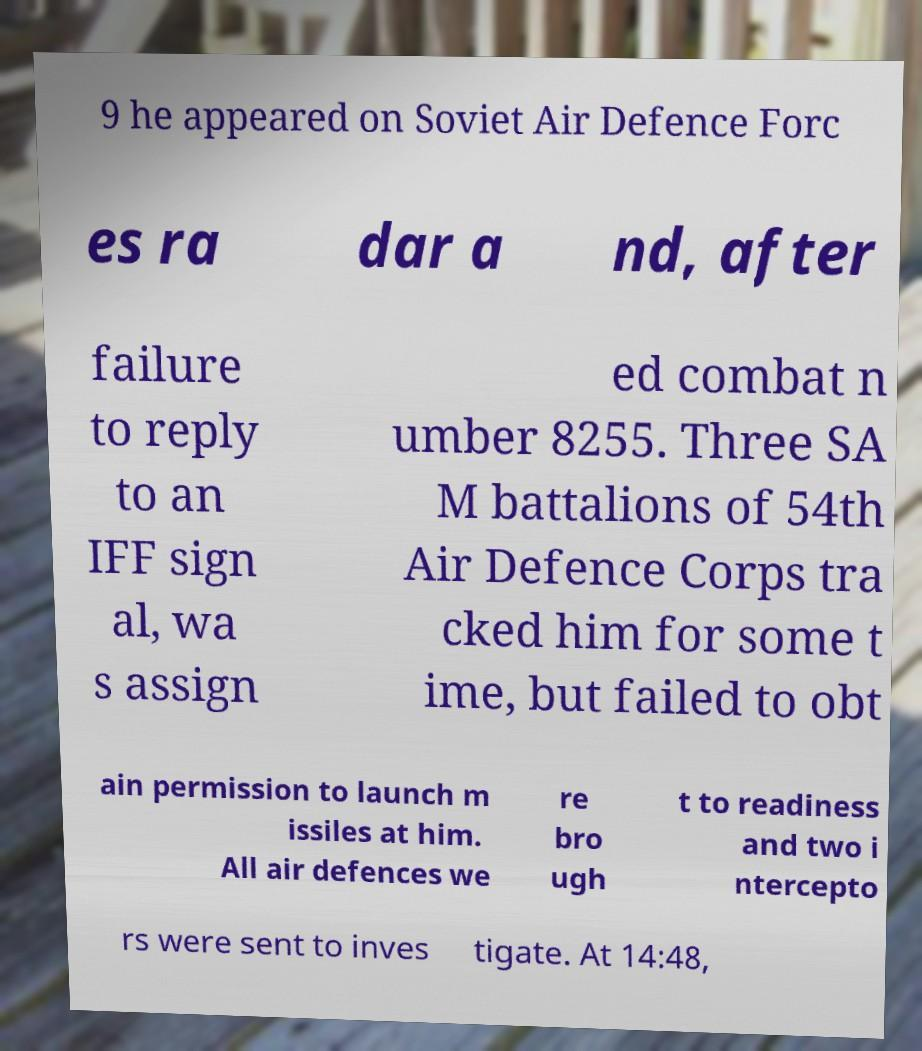Could you assist in decoding the text presented in this image and type it out clearly? 9 he appeared on Soviet Air Defence Forc es ra dar a nd, after failure to reply to an IFF sign al, wa s assign ed combat n umber 8255. Three SA M battalions of 54th Air Defence Corps tra cked him for some t ime, but failed to obt ain permission to launch m issiles at him. All air defences we re bro ugh t to readiness and two i ntercepto rs were sent to inves tigate. At 14:48, 